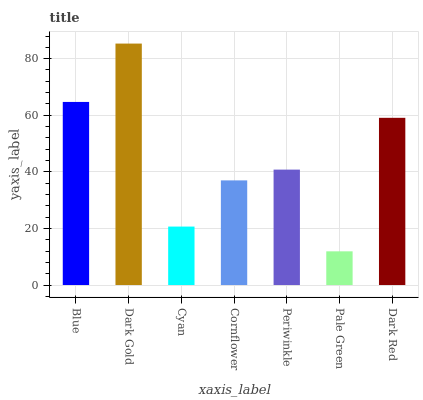Is Pale Green the minimum?
Answer yes or no. Yes. Is Dark Gold the maximum?
Answer yes or no. Yes. Is Cyan the minimum?
Answer yes or no. No. Is Cyan the maximum?
Answer yes or no. No. Is Dark Gold greater than Cyan?
Answer yes or no. Yes. Is Cyan less than Dark Gold?
Answer yes or no. Yes. Is Cyan greater than Dark Gold?
Answer yes or no. No. Is Dark Gold less than Cyan?
Answer yes or no. No. Is Periwinkle the high median?
Answer yes or no. Yes. Is Periwinkle the low median?
Answer yes or no. Yes. Is Cyan the high median?
Answer yes or no. No. Is Pale Green the low median?
Answer yes or no. No. 